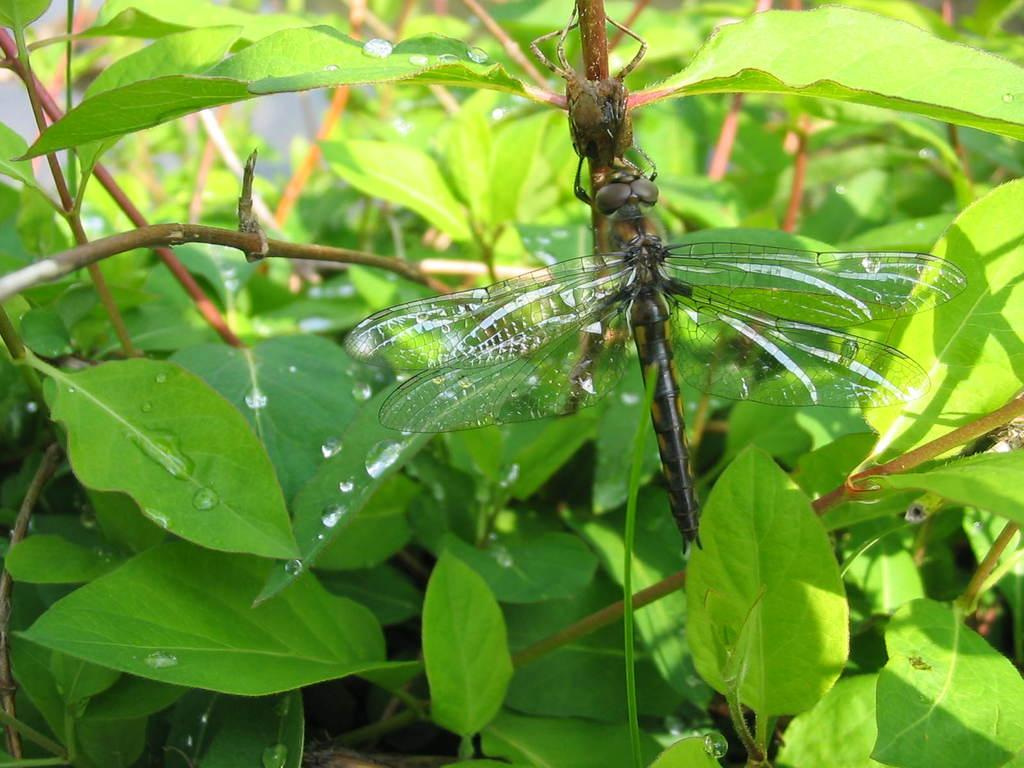What type of insect is present in the image? There is a dragonfly in the image. What else can be seen in the image besides the dragonfly? There are leaves with water drops in the image. What type of oatmeal is being served in the image? There is no oatmeal present in the image; it features a dragonfly and leaves with water drops. 